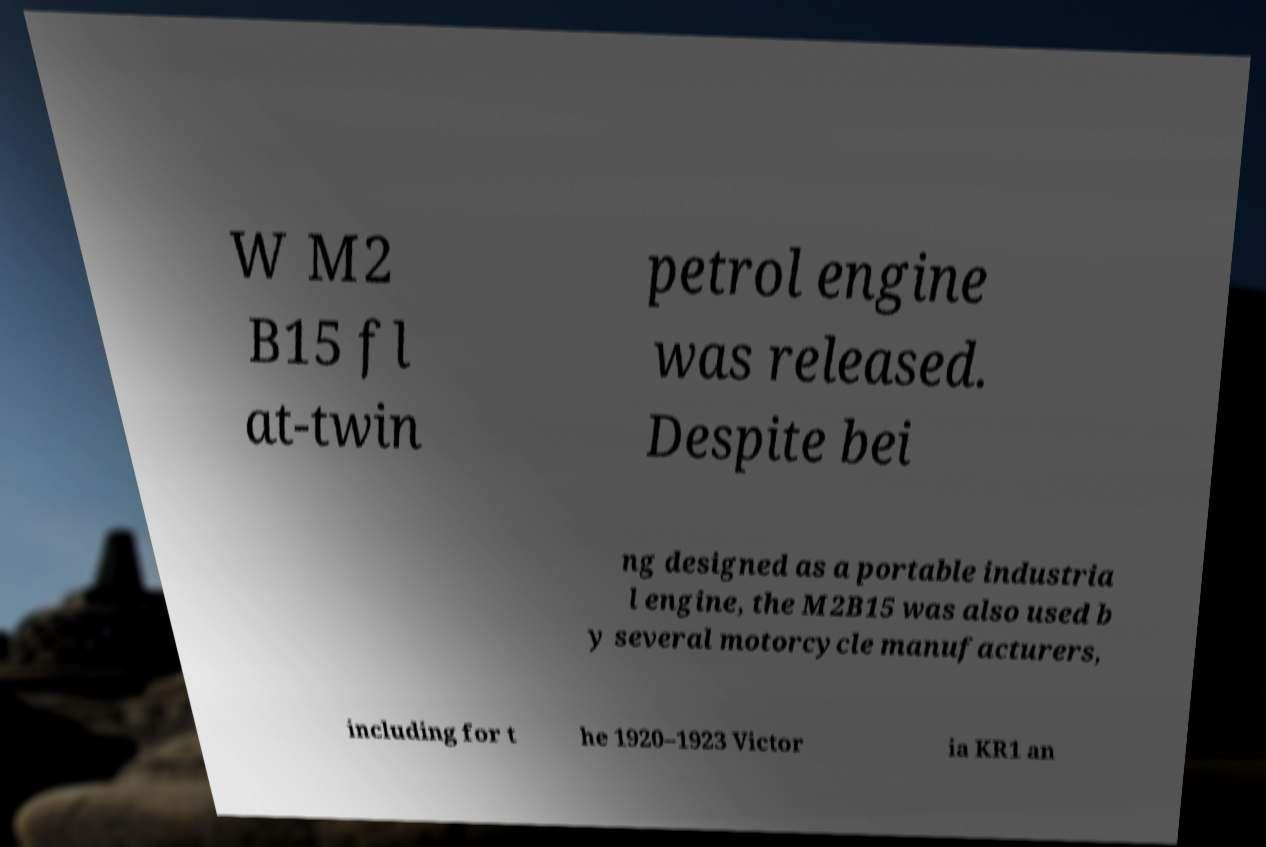Can you read and provide the text displayed in the image?This photo seems to have some interesting text. Can you extract and type it out for me? W M2 B15 fl at-twin petrol engine was released. Despite bei ng designed as a portable industria l engine, the M2B15 was also used b y several motorcycle manufacturers, including for t he 1920–1923 Victor ia KR1 an 